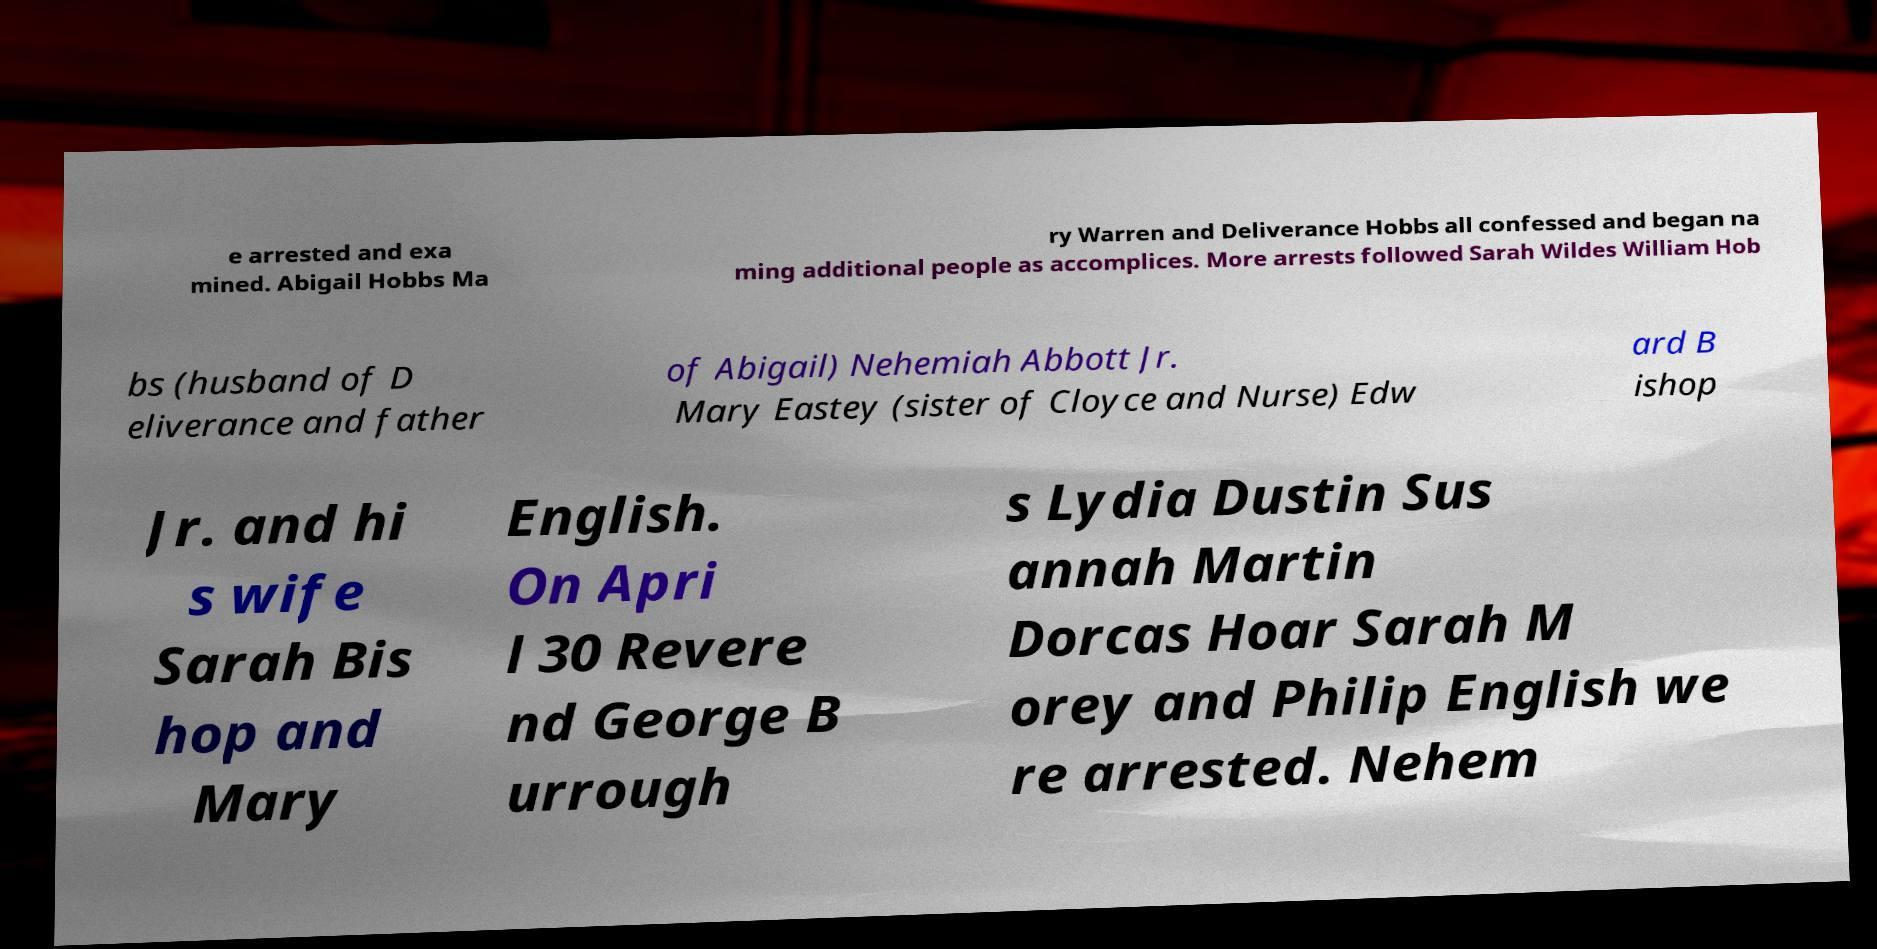For documentation purposes, I need the text within this image transcribed. Could you provide that? e arrested and exa mined. Abigail Hobbs Ma ry Warren and Deliverance Hobbs all confessed and began na ming additional people as accomplices. More arrests followed Sarah Wildes William Hob bs (husband of D eliverance and father of Abigail) Nehemiah Abbott Jr. Mary Eastey (sister of Cloyce and Nurse) Edw ard B ishop Jr. and hi s wife Sarah Bis hop and Mary English. On Apri l 30 Revere nd George B urrough s Lydia Dustin Sus annah Martin Dorcas Hoar Sarah M orey and Philip English we re arrested. Nehem 